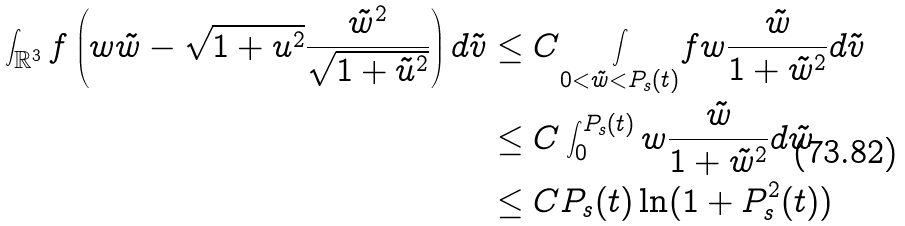Convert formula to latex. <formula><loc_0><loc_0><loc_500><loc_500>\int _ { \mathbb { R } ^ { 3 } } f \left ( w \tilde { w } - \sqrt { 1 + u ^ { 2 } } \frac { \tilde { w } ^ { 2 } } { \sqrt { 1 + \tilde { u } ^ { 2 } } } \right ) d \tilde { v } & \leq C \underset { 0 < \tilde { w } < P _ { s } ( t ) } { \int } f w \frac { \tilde { w } } { 1 + \tilde { w } ^ { 2 } } d \tilde { v } \\ & \leq C \int _ { 0 } ^ { P _ { s } ( t ) } w \frac { \tilde { w } } { 1 + \tilde { w } ^ { 2 } } d \tilde { w } \\ & \leq C P _ { s } ( t ) \ln ( 1 + P _ { s } ^ { 2 } ( t ) )</formula> 